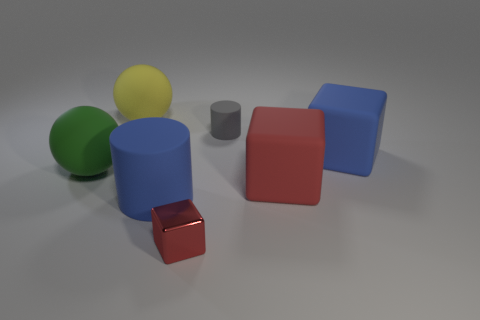Add 1 small cylinders. How many objects exist? 8 Subtract all balls. How many objects are left? 5 Subtract 0 cyan blocks. How many objects are left? 7 Subtract all rubber spheres. Subtract all tiny red shiny things. How many objects are left? 4 Add 6 big rubber cylinders. How many big rubber cylinders are left? 7 Add 3 yellow matte spheres. How many yellow matte spheres exist? 4 